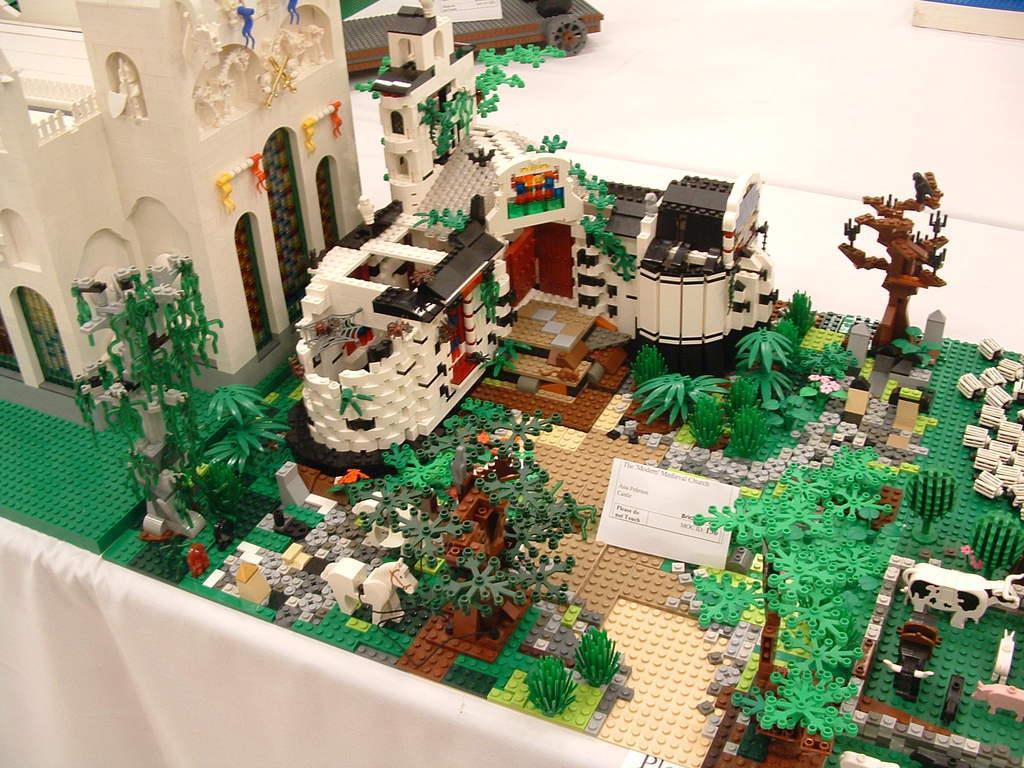Could you give a brief overview of what you see in this image? In this image we can see a building, houses, trees, vehicles, cows and the seeds which are built with the Lego blocks placed on the table. We can also see a paper with some text on it. 